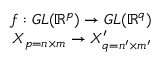<formula> <loc_0><loc_0><loc_500><loc_500>\begin{array} { r } { f \colon G L ( \mathbb { R } ^ { p } ) \rightarrow G L ( \mathbb { R } ^ { q } ) } \\ { X _ { p = n \times m } \rightarrow X _ { q = n ^ { \prime } \times m ^ { \prime } } ^ { \prime } } \end{array}</formula> 